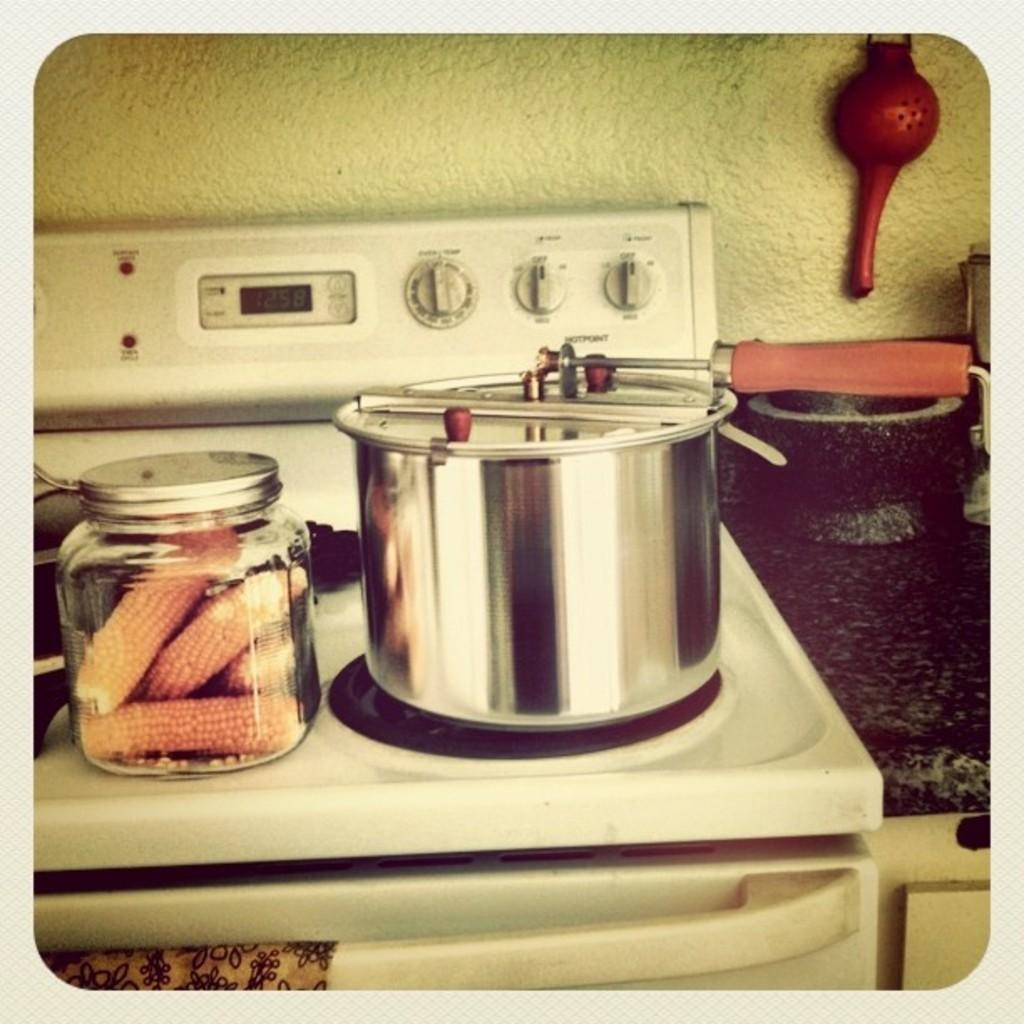<image>
Share a concise interpretation of the image provided. A white stove with a digital clock showing 12:58 on the screen 